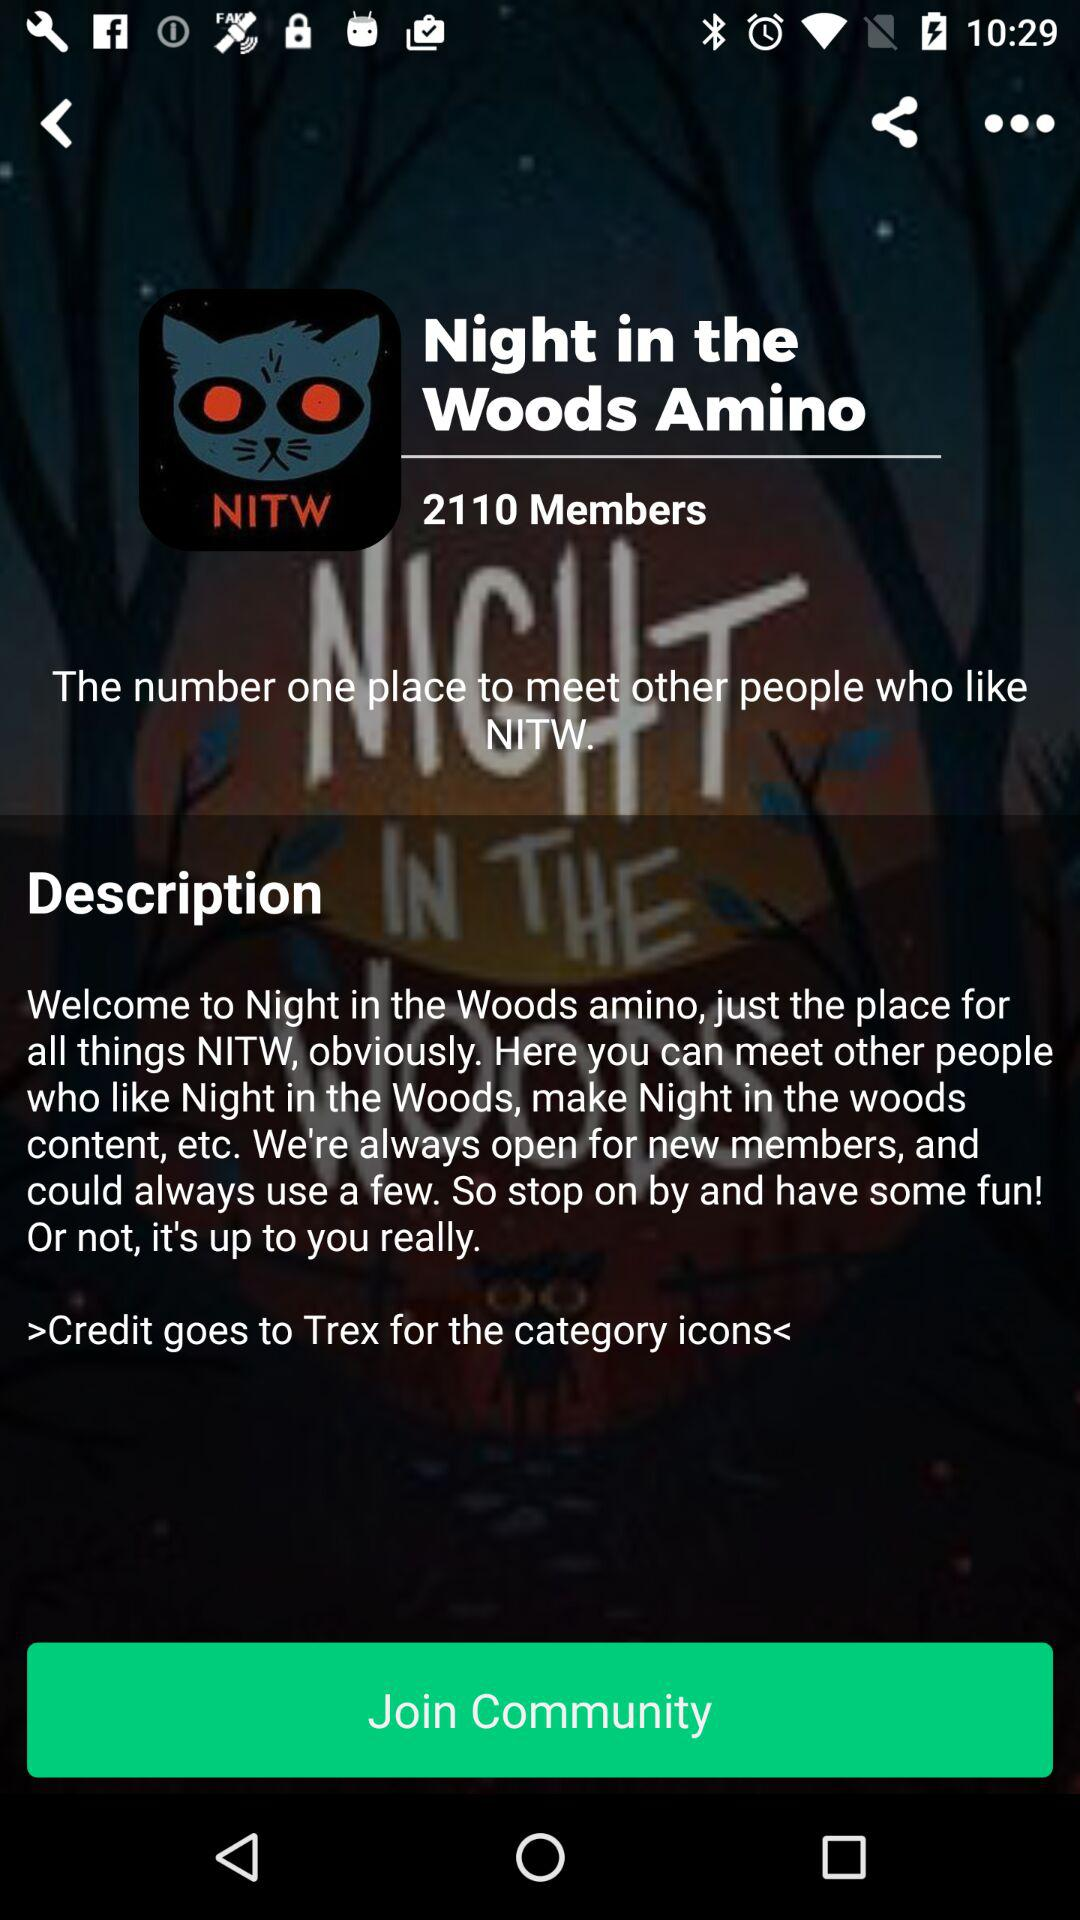How many members have joined the "Night in the Woods Amino" community? The number of members who have joined the "Night in the Woods Amino" community is 2110. 